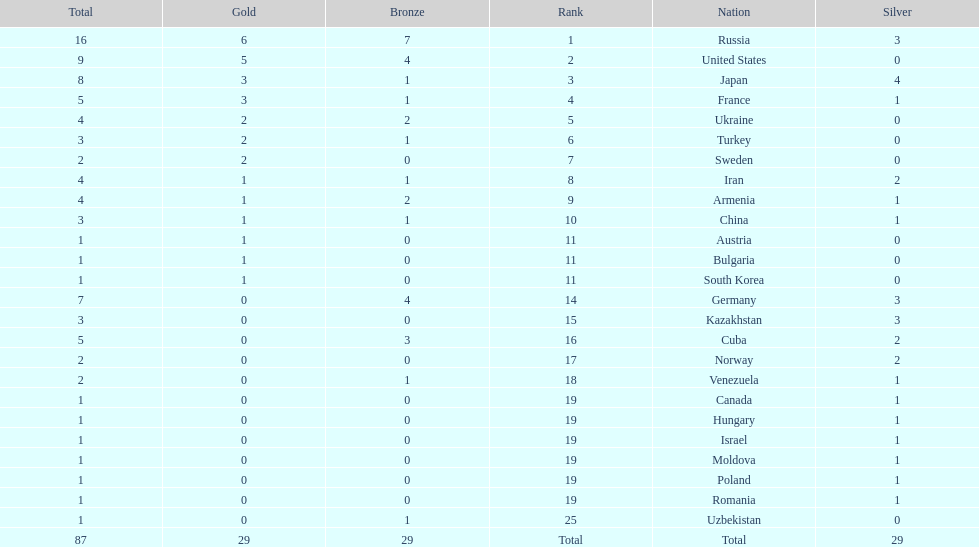How many combined gold medals did japan and france win? 6. 